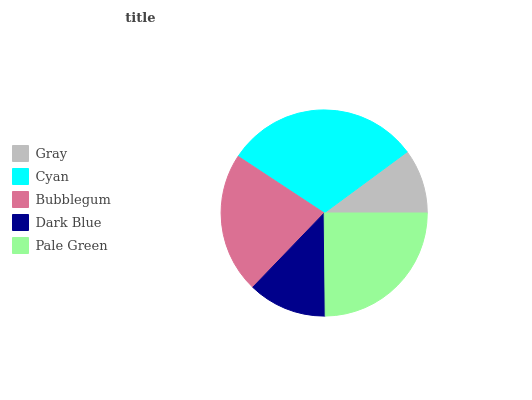Is Gray the minimum?
Answer yes or no. Yes. Is Cyan the maximum?
Answer yes or no. Yes. Is Bubblegum the minimum?
Answer yes or no. No. Is Bubblegum the maximum?
Answer yes or no. No. Is Cyan greater than Bubblegum?
Answer yes or no. Yes. Is Bubblegum less than Cyan?
Answer yes or no. Yes. Is Bubblegum greater than Cyan?
Answer yes or no. No. Is Cyan less than Bubblegum?
Answer yes or no. No. Is Bubblegum the high median?
Answer yes or no. Yes. Is Bubblegum the low median?
Answer yes or no. Yes. Is Cyan the high median?
Answer yes or no. No. Is Pale Green the low median?
Answer yes or no. No. 